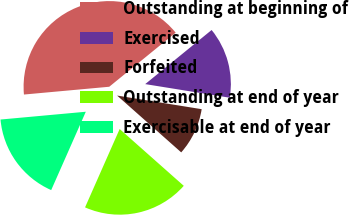<chart> <loc_0><loc_0><loc_500><loc_500><pie_chart><fcel>Outstanding at beginning of<fcel>Exercised<fcel>Forfeited<fcel>Outstanding at end of year<fcel>Exercisable at end of year<nl><fcel>40.57%<fcel>13.42%<fcel>9.0%<fcel>20.08%<fcel>16.93%<nl></chart> 